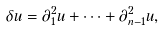<formula> <loc_0><loc_0><loc_500><loc_500>\delta u = \partial ^ { 2 } _ { 1 } u + \cdots + \partial ^ { 2 } _ { n - 1 } u ,</formula> 